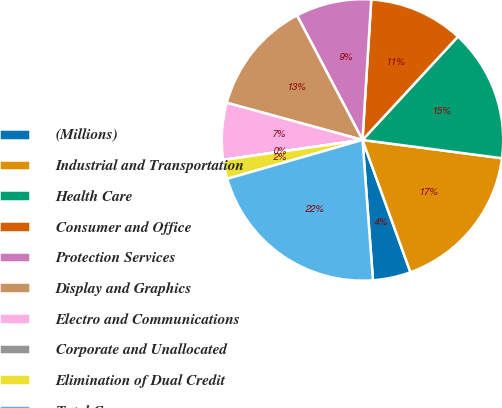Convert chart to OTSL. <chart><loc_0><loc_0><loc_500><loc_500><pie_chart><fcel>(Millions)<fcel>Industrial and Transportation<fcel>Health Care<fcel>Consumer and Office<fcel>Protection Services<fcel>Display and Graphics<fcel>Electro and Communications<fcel>Corporate and Unallocated<fcel>Elimination of Dual Credit<fcel>Total Company<nl><fcel>4.35%<fcel>17.39%<fcel>15.21%<fcel>10.87%<fcel>8.7%<fcel>13.04%<fcel>6.52%<fcel>0.01%<fcel>2.18%<fcel>21.73%<nl></chart> 